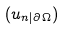Convert formula to latex. <formula><loc_0><loc_0><loc_500><loc_500>( u _ { n | \partial \Omega } )</formula> 